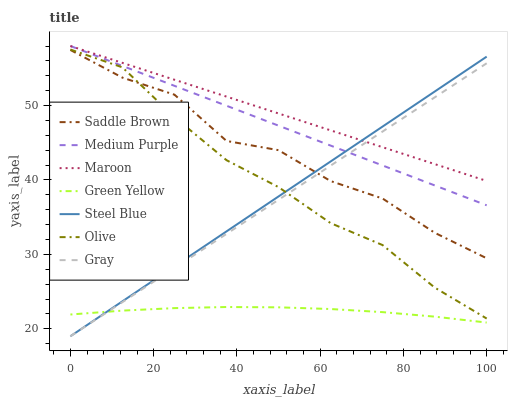Does Green Yellow have the minimum area under the curve?
Answer yes or no. Yes. Does Maroon have the maximum area under the curve?
Answer yes or no. Yes. Does Steel Blue have the minimum area under the curve?
Answer yes or no. No. Does Steel Blue have the maximum area under the curve?
Answer yes or no. No. Is Maroon the smoothest?
Answer yes or no. Yes. Is Saddle Brown the roughest?
Answer yes or no. Yes. Is Steel Blue the smoothest?
Answer yes or no. No. Is Steel Blue the roughest?
Answer yes or no. No. Does Gray have the lowest value?
Answer yes or no. Yes. Does Maroon have the lowest value?
Answer yes or no. No. Does Medium Purple have the highest value?
Answer yes or no. Yes. Does Steel Blue have the highest value?
Answer yes or no. No. Is Green Yellow less than Medium Purple?
Answer yes or no. Yes. Is Medium Purple greater than Olive?
Answer yes or no. Yes. Does Maroon intersect Gray?
Answer yes or no. Yes. Is Maroon less than Gray?
Answer yes or no. No. Is Maroon greater than Gray?
Answer yes or no. No. Does Green Yellow intersect Medium Purple?
Answer yes or no. No. 